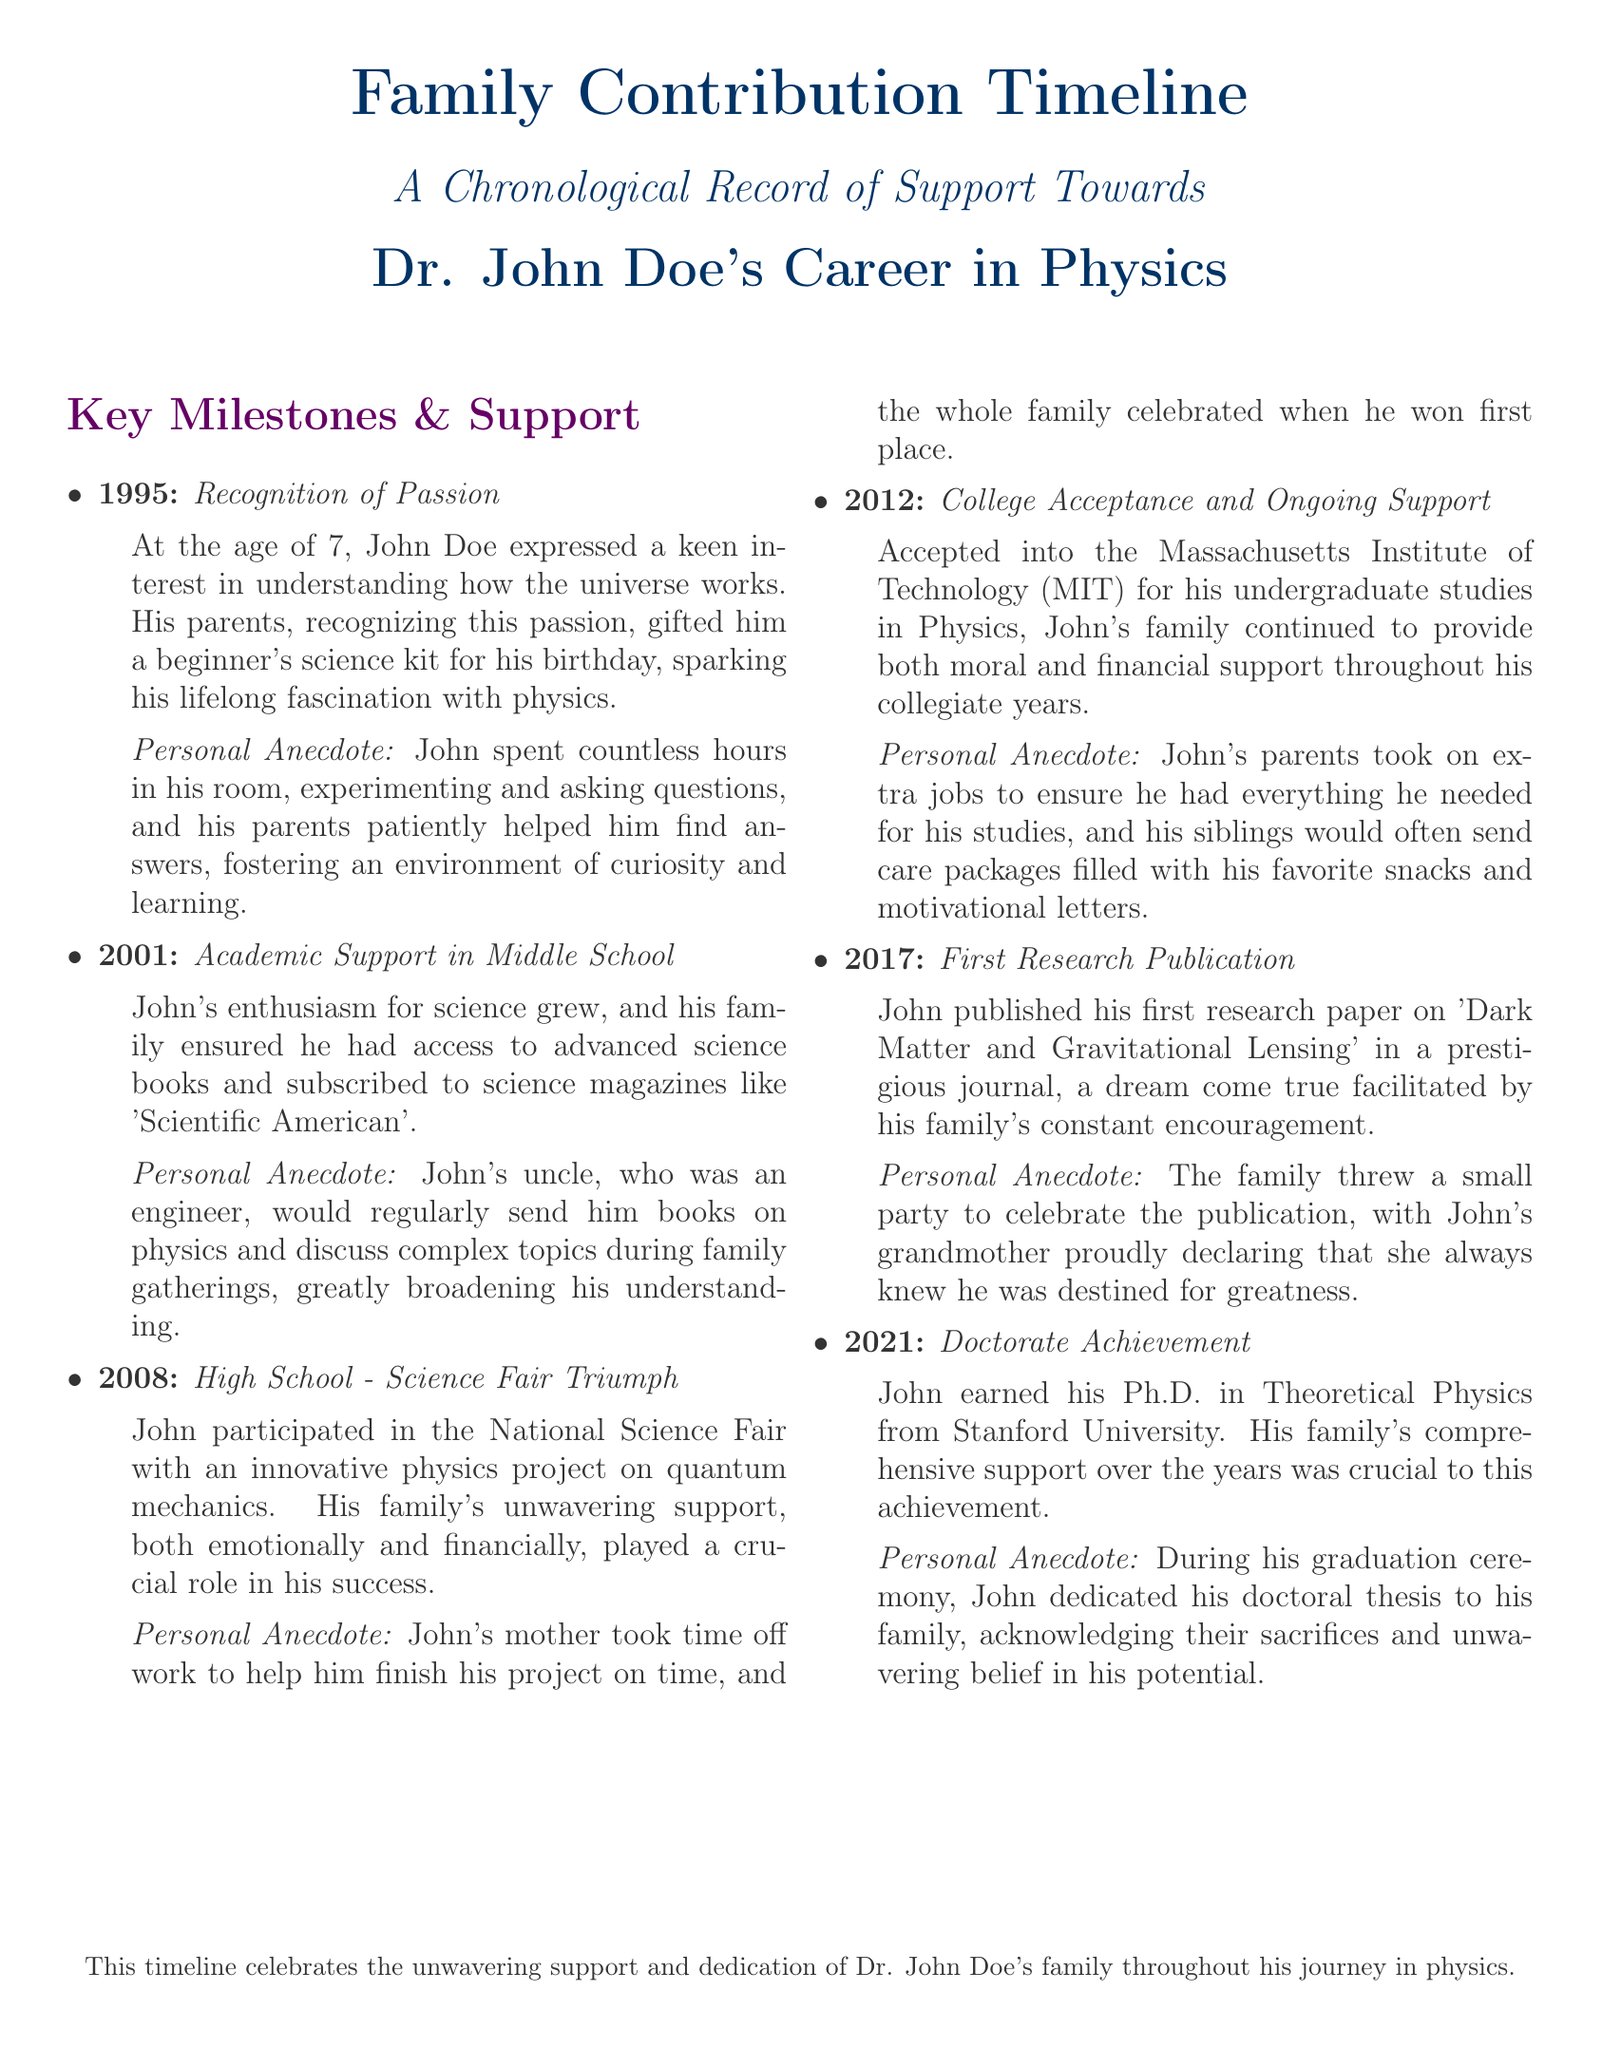What year did John Doe express his keen interest in science? The document states that John Doe expressed his interest in science at the age of 7 in 1995.
Answer: 1995 What was gifted to John for his birthday in 1995? The document mentions a beginner's science kit was gifted to John for his birthday.
Answer: beginner's science kit Who helped John with his science fair project in high school? The document indicates that John's mother helped him finish his project on time for the science fair.
Answer: his mother Which university did John attend for his undergraduate studies? According to the document, John was accepted into the Massachusetts Institute of Technology for his undergraduate studies.
Answer: Massachusetts Institute of Technology What was the title of John's first research paper published in 2017? The document refers to John's first research paper titled 'Dark Matter and Gravitational Lensing.'
Answer: Dark Matter and Gravitational Lensing What significant milestone did John achieve in 2021? The document states that John earned his Ph.D. in Theoretical Physics in 2021.
Answer: Ph.D. in Theoretical Physics How did John's family celebrate his first research publication? According to the document, John's family threw a small party to celebrate his publication.
Answer: small party What type of support did John's family provide throughout his collegiate years? The document highlights that John's family provided both moral and financial support during his college years.
Answer: moral and financial support What personal anecdote is associated with the recognition of John's passion for science? The document includes that John spent hours experimenting and his parents helped him find answers, fostering curiosity.
Answer: fostering curiosity and learning 